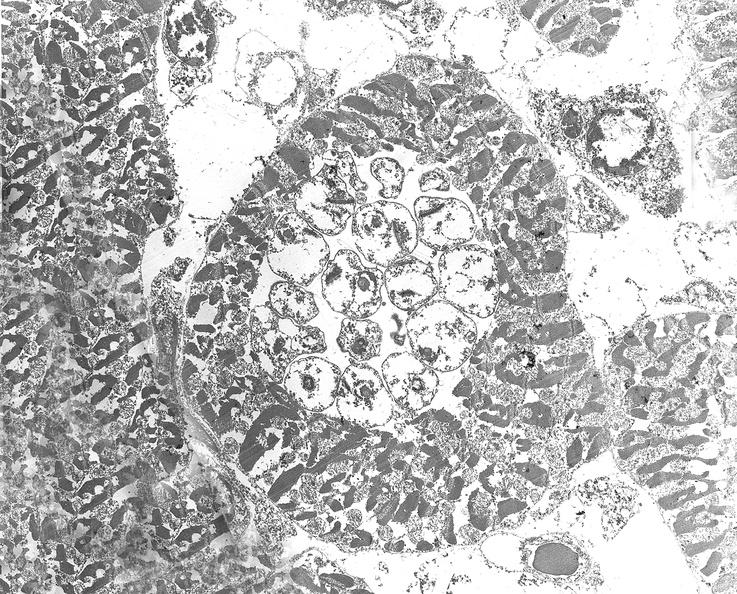s cardiovascular present?
Answer the question using a single word or phrase. Yes 